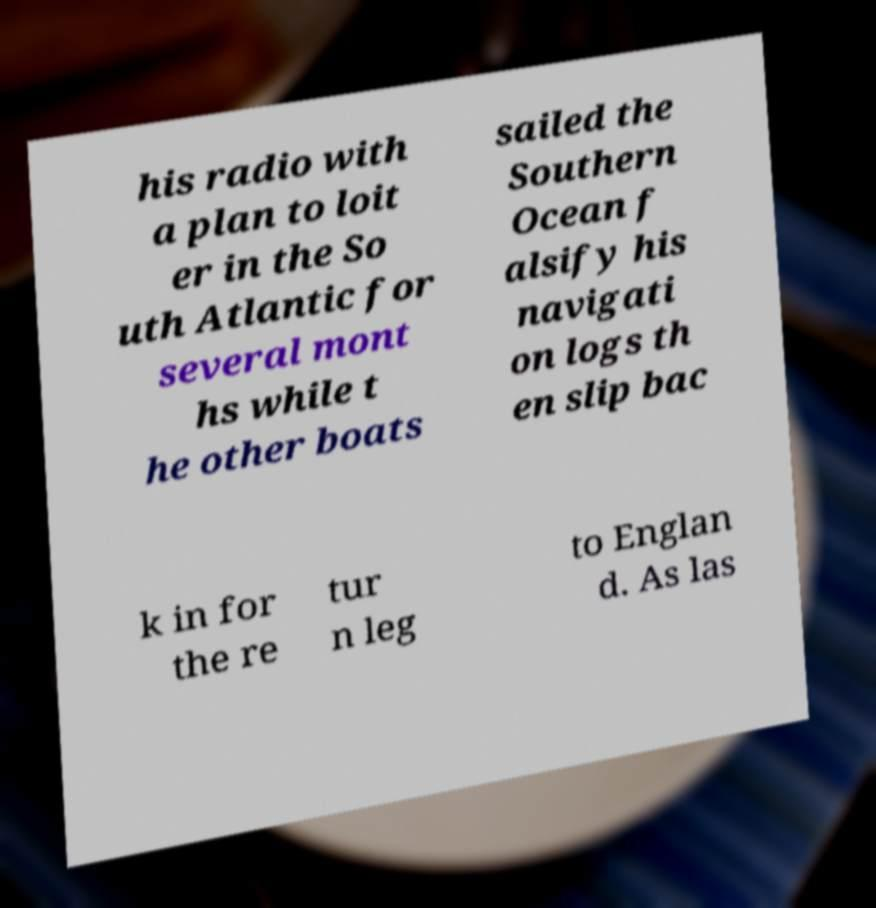What messages or text are displayed in this image? I need them in a readable, typed format. his radio with a plan to loit er in the So uth Atlantic for several mont hs while t he other boats sailed the Southern Ocean f alsify his navigati on logs th en slip bac k in for the re tur n leg to Englan d. As las 